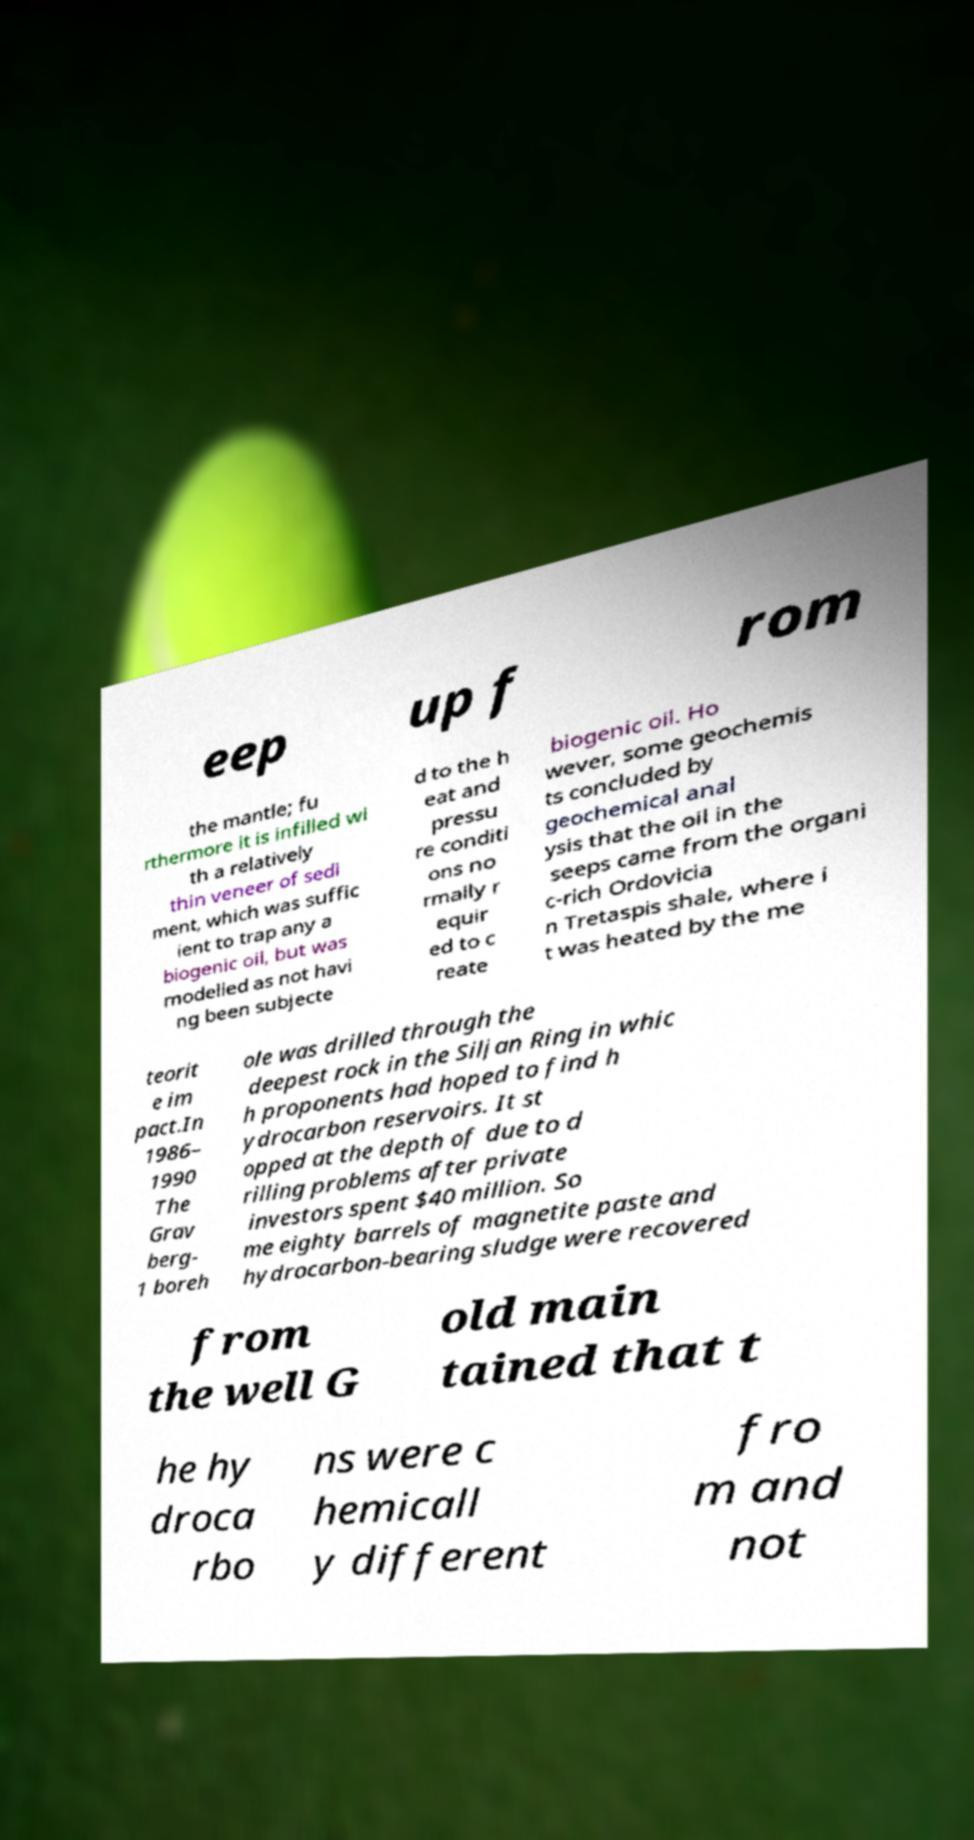Can you read and provide the text displayed in the image?This photo seems to have some interesting text. Can you extract and type it out for me? eep up f rom the mantle; fu rthermore it is infilled wi th a relatively thin veneer of sedi ment, which was suffic ient to trap any a biogenic oil, but was modelled as not havi ng been subjecte d to the h eat and pressu re conditi ons no rmally r equir ed to c reate biogenic oil. Ho wever, some geochemis ts concluded by geochemical anal ysis that the oil in the seeps came from the organi c-rich Ordovicia n Tretaspis shale, where i t was heated by the me teorit e im pact.In 1986– 1990 The Grav berg- 1 boreh ole was drilled through the deepest rock in the Siljan Ring in whic h proponents had hoped to find h ydrocarbon reservoirs. It st opped at the depth of due to d rilling problems after private investors spent $40 million. So me eighty barrels of magnetite paste and hydrocarbon-bearing sludge were recovered from the well G old main tained that t he hy droca rbo ns were c hemicall y different fro m and not 